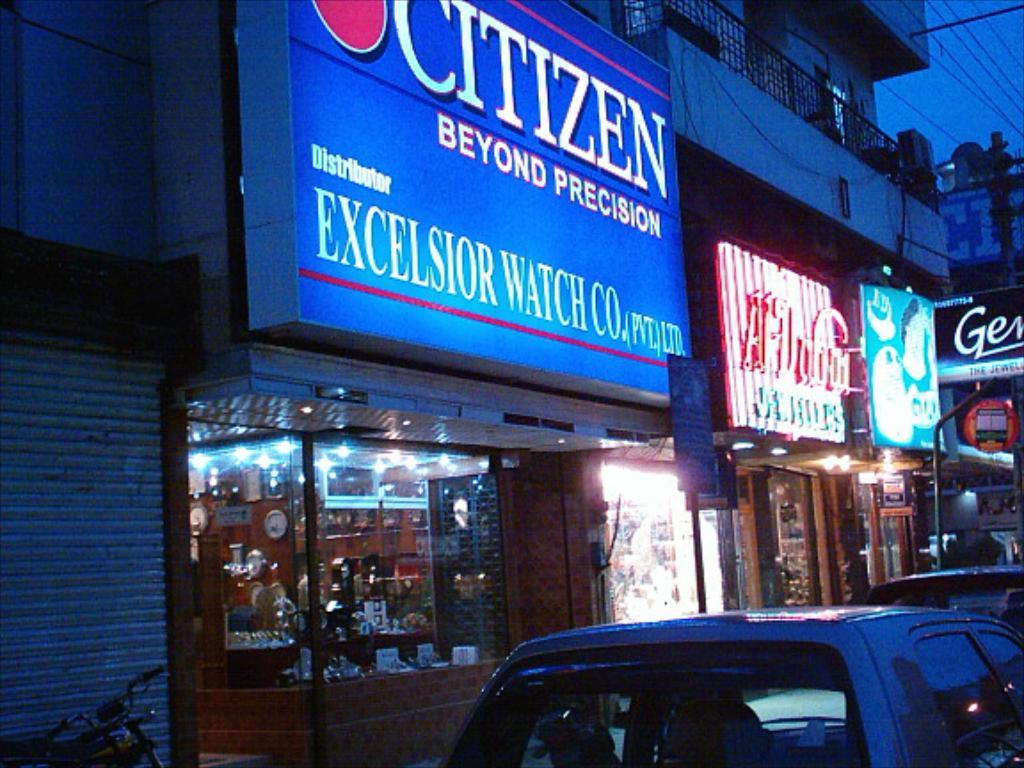What type of motor vehicle can be seen on the road in the image? There is a motor vehicle on the road in the image, but the specific type is not mentioned. What kind of establishments are present in the image? There are stores in the image. What signage is visible in the image? Name boards are present in the image. What architectural feature can be seen in the image? Grills are visible in the image. What type of structures are present in the image? Buildings are present in the image. What infrastructure elements are visible in the image? Cables and a street pole are visible in the image. What lighting features are present in the image? There is a street light and electric lights visible in the image. What type of tin is being sold at the stores in the image? There is no mention of tin being sold at the stores in the image. How can one purchase a ticket for the motor vehicle in the image? There is no indication of a motor vehicle being for sale or requiring a ticket in the image. 